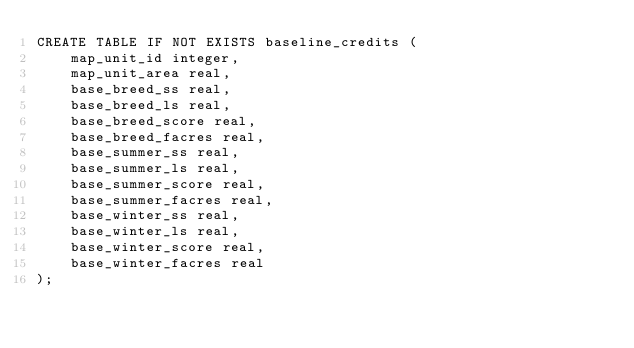Convert code to text. <code><loc_0><loc_0><loc_500><loc_500><_SQL_>CREATE TABLE IF NOT EXISTS baseline_credits (
    map_unit_id integer,
    map_unit_area real,
    base_breed_ss real,
    base_breed_ls real,
    base_breed_score real,
    base_breed_facres real,
    base_summer_ss real,
    base_summer_ls real,
    base_summer_score real,
    base_summer_facres real,
    base_winter_ss real,
    base_winter_ls real,
    base_winter_score real,
    base_winter_facres real
);</code> 